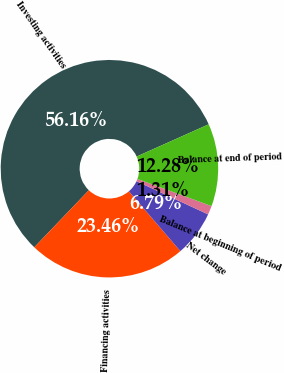<chart> <loc_0><loc_0><loc_500><loc_500><pie_chart><fcel>Investing activities<fcel>Financing activities<fcel>Net change<fcel>Balance at beginning of period<fcel>Balance at end of period<nl><fcel>56.17%<fcel>23.46%<fcel>6.79%<fcel>1.31%<fcel>12.28%<nl></chart> 